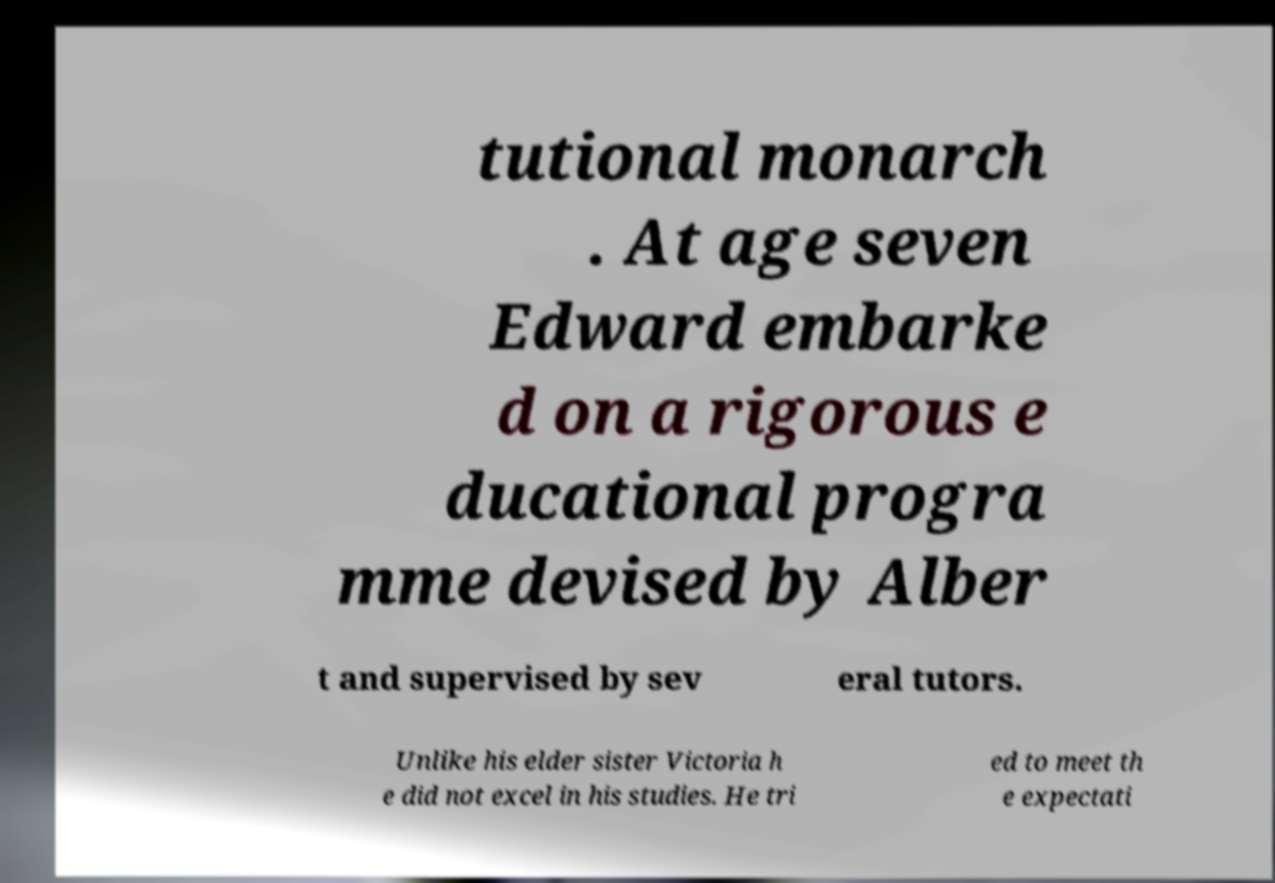Could you extract and type out the text from this image? tutional monarch . At age seven Edward embarke d on a rigorous e ducational progra mme devised by Alber t and supervised by sev eral tutors. Unlike his elder sister Victoria h e did not excel in his studies. He tri ed to meet th e expectati 